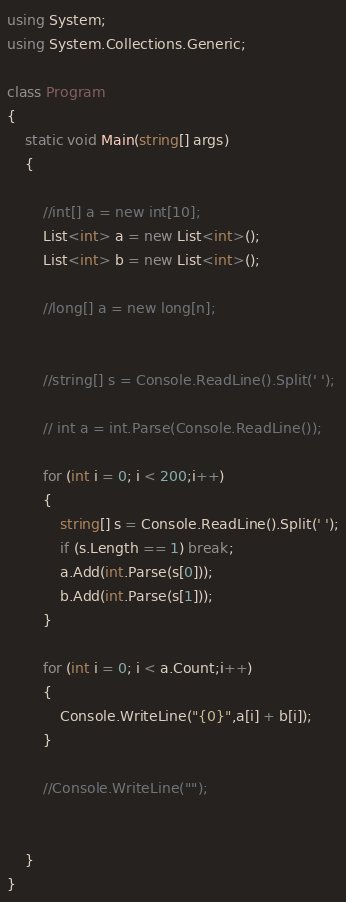Convert code to text. <code><loc_0><loc_0><loc_500><loc_500><_C#_>using System;
using System.Collections.Generic;

class Program
{
	static void Main(string[] args)
	{

        //int[] a = new int[10];
        List<int> a = new List<int>();
        List<int> b = new List<int>();

        //long[] a = new long[n];


        //string[] s = Console.ReadLine().Split(' ');

        // int a = int.Parse(Console.ReadLine());

        for (int i = 0; i < 200;i++)
        {
            string[] s = Console.ReadLine().Split(' ');
            if (s.Length == 1) break;
            a.Add(int.Parse(s[0]));
            b.Add(int.Parse(s[1]));
        }

        for (int i = 0; i < a.Count;i++)
        {
            Console.WriteLine("{0}",a[i] + b[i]);
        }

		//Console.WriteLine("");


	}
}</code> 